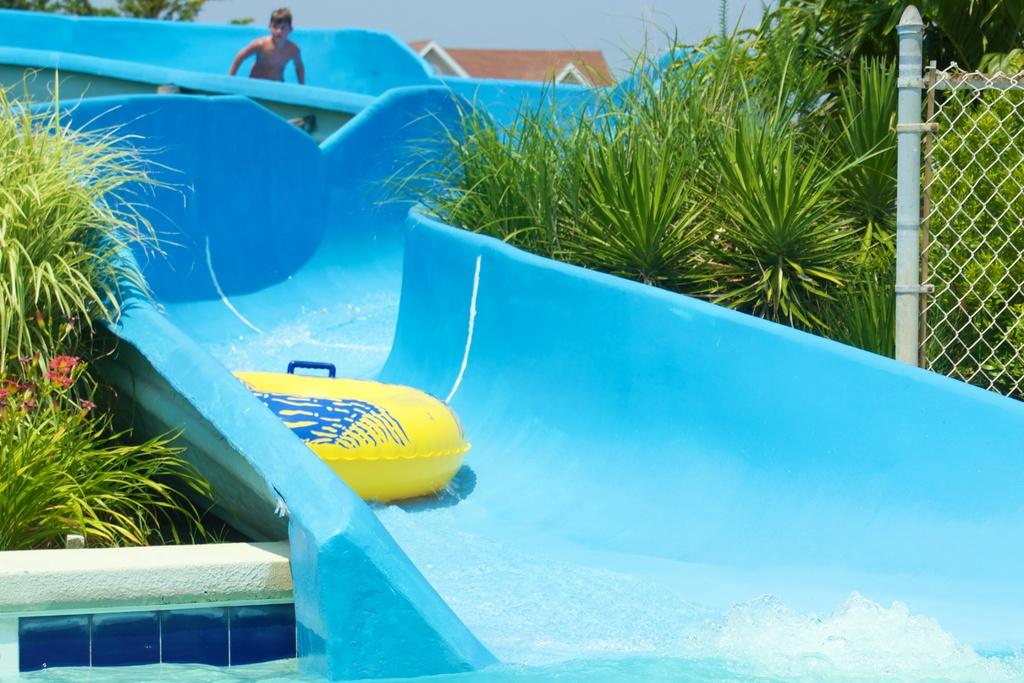What is the main object in the image? There is a slide in the image. Is there anyone using the slide? Yes, a person is on the slide. What other objects can be seen in the image? There is a swim tube in the image. What can be seen in the background of the image? There are plants, a fence, a roof, flowers, and water visible in the background of the image. Can you see the agreement being signed on the slide in the image? There is no agreement being signed in the image; it features a slide with a person on it and a swim tube. Are there any fangs visible on the person using the slide? There are no fangs visible on the person using the slide; they are simply enjoying the slide. 